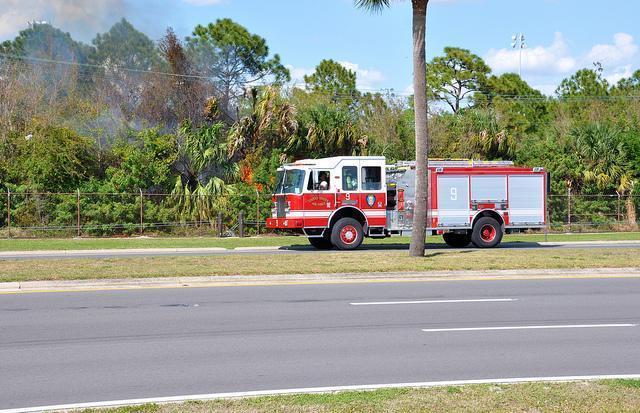How many trees are in front on the fire truck?
Give a very brief answer. 1. How many news anchors are on the television screen?
Give a very brief answer. 0. 